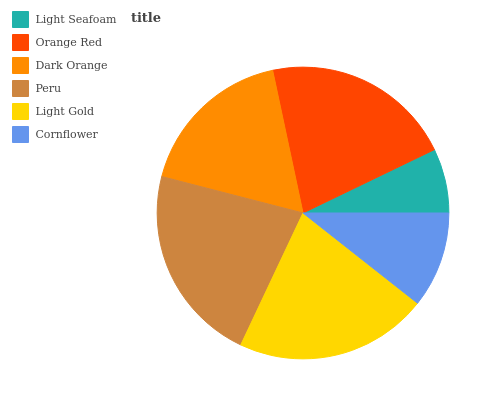Is Light Seafoam the minimum?
Answer yes or no. Yes. Is Peru the maximum?
Answer yes or no. Yes. Is Orange Red the minimum?
Answer yes or no. No. Is Orange Red the maximum?
Answer yes or no. No. Is Orange Red greater than Light Seafoam?
Answer yes or no. Yes. Is Light Seafoam less than Orange Red?
Answer yes or no. Yes. Is Light Seafoam greater than Orange Red?
Answer yes or no. No. Is Orange Red less than Light Seafoam?
Answer yes or no. No. Is Orange Red the high median?
Answer yes or no. Yes. Is Dark Orange the low median?
Answer yes or no. Yes. Is Dark Orange the high median?
Answer yes or no. No. Is Light Gold the low median?
Answer yes or no. No. 